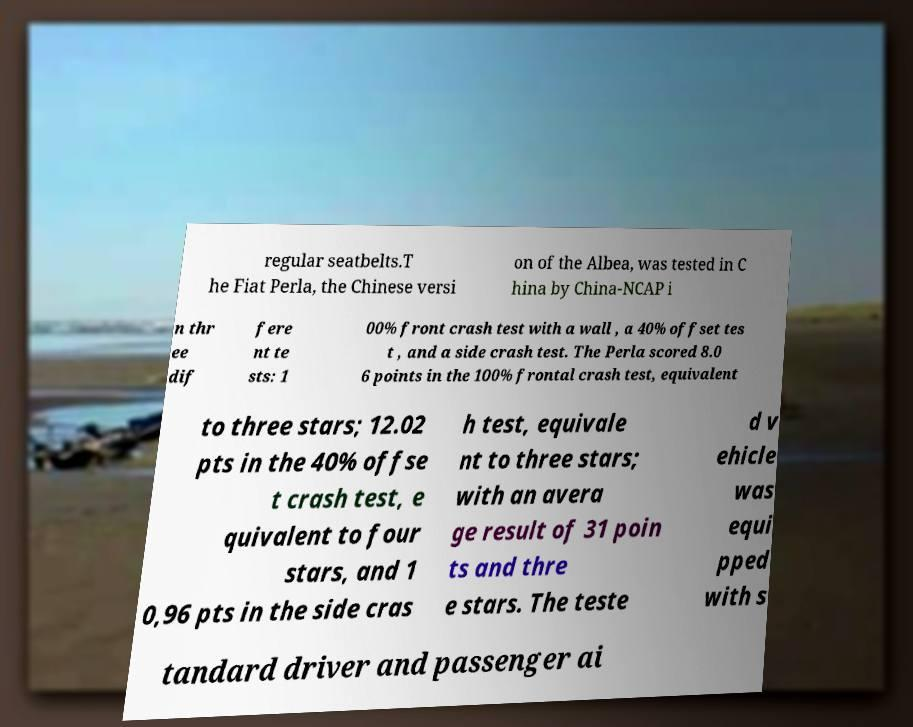I need the written content from this picture converted into text. Can you do that? regular seatbelts.T he Fiat Perla, the Chinese versi on of the Albea, was tested in C hina by China-NCAP i n thr ee dif fere nt te sts: 1 00% front crash test with a wall , a 40% offset tes t , and a side crash test. The Perla scored 8.0 6 points in the 100% frontal crash test, equivalent to three stars; 12.02 pts in the 40% offse t crash test, e quivalent to four stars, and 1 0,96 pts in the side cras h test, equivale nt to three stars; with an avera ge result of 31 poin ts and thre e stars. The teste d v ehicle was equi pped with s tandard driver and passenger ai 